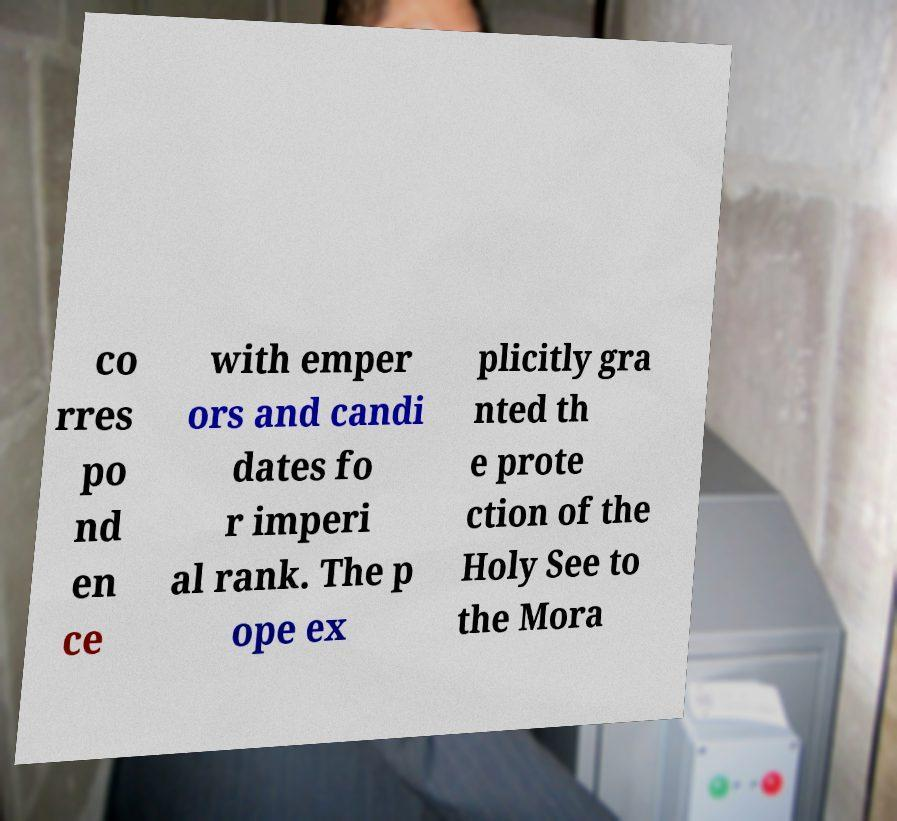There's text embedded in this image that I need extracted. Can you transcribe it verbatim? co rres po nd en ce with emper ors and candi dates fo r imperi al rank. The p ope ex plicitly gra nted th e prote ction of the Holy See to the Mora 